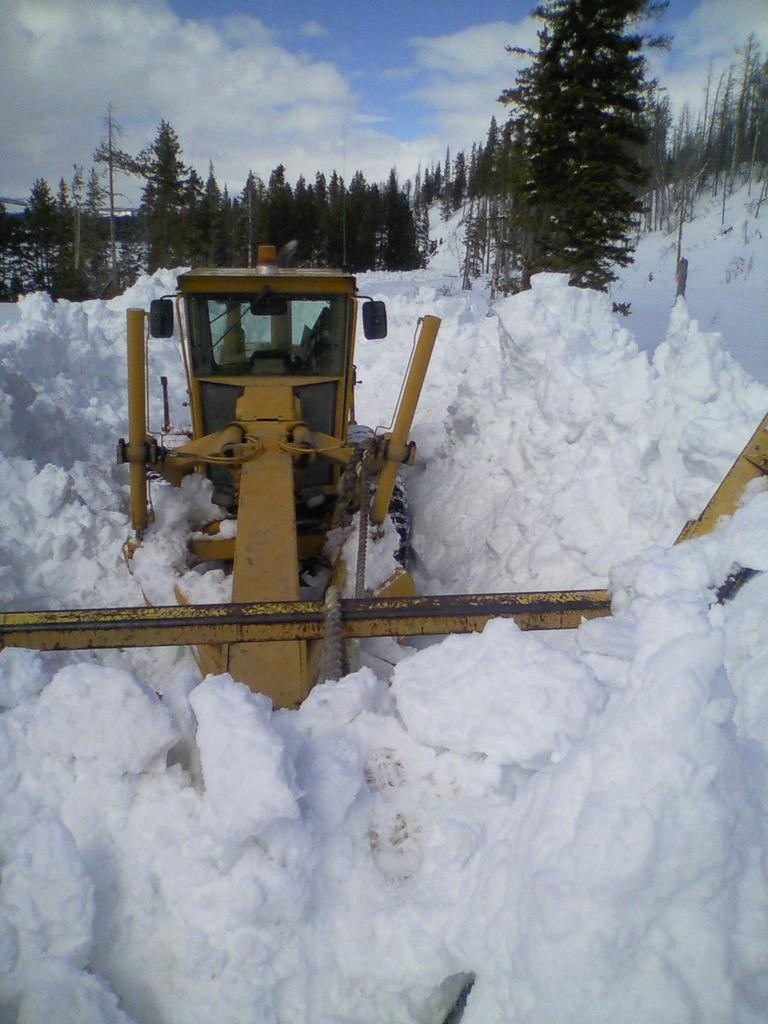What is the main subject of the image? There is a snow cleaning machine in the image. What can be seen in the background of the image? The background of the image includes sky with clouds and trees. What type of weather is depicted in the image? Snow is present in the image. Can you tell me how many donkeys are pulling the snow cleaning machine in the image? There are no donkeys present in the image; the snow cleaning machine is likely powered by an engine or other mechanical means. 